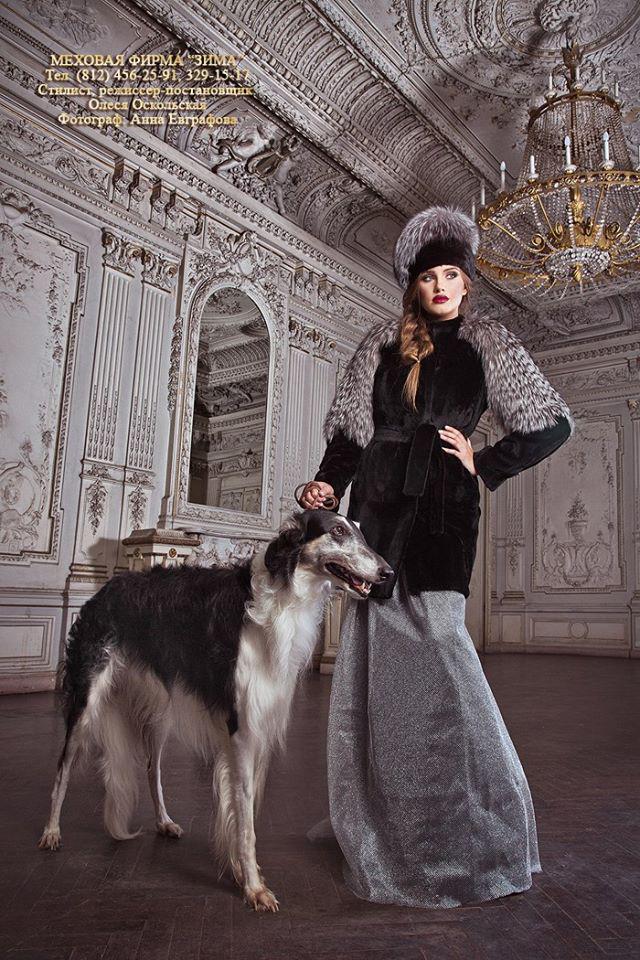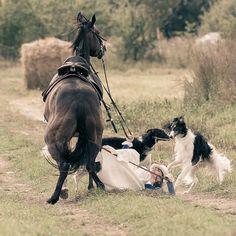The first image is the image on the left, the second image is the image on the right. Given the left and right images, does the statement "Each image contains one silky haired white afghan hound, and one dog has his head lowered to the left." hold true? Answer yes or no. No. The first image is the image on the left, the second image is the image on the right. Assess this claim about the two images: "One of the dogs is in the snow.". Correct or not? Answer yes or no. No. 